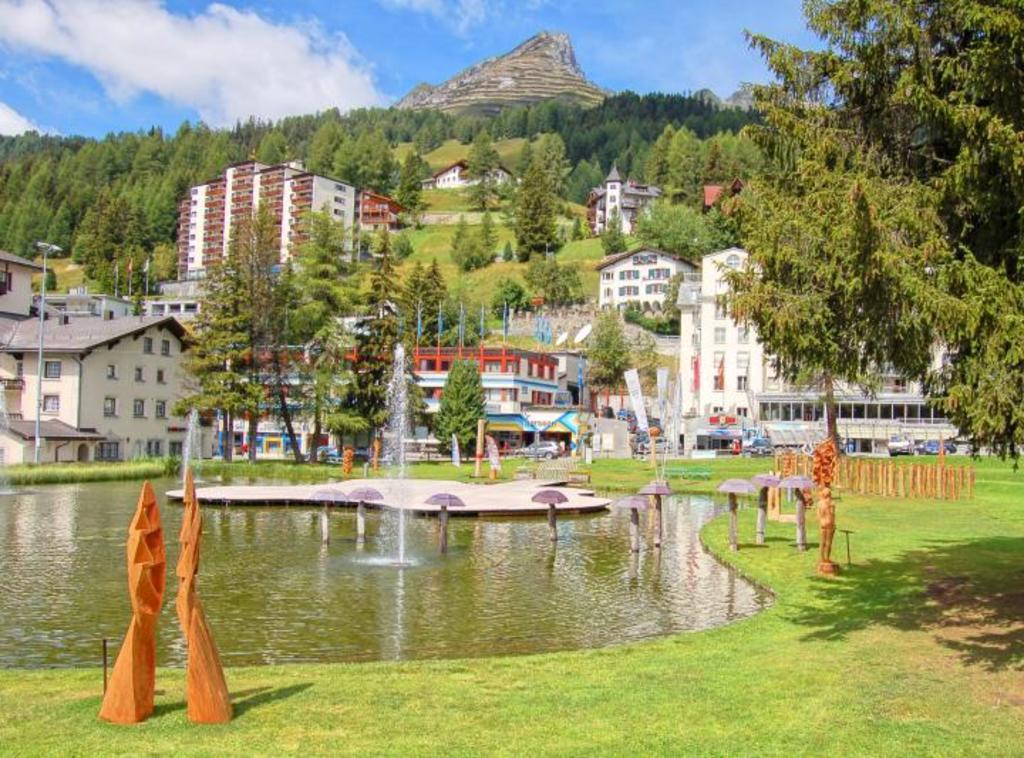What is the main feature in the center of the image? There is water in the center of the image. What can be seen inside the water? There are fountains in the water. What type of structures can be seen in the background of the image? There are buildings in the background of the image. What type of vegetation is visible in the background of the image? Trees are present in the background of the image. What type of natural landform is visible in the background of the image? There are mountains in the background of the image. What type of ground cover is present at the bottom of the image? There is grass at the bottom of the image. How many eggs are being used to lock the bike in the image? There are no eggs or bikes present in the image. 